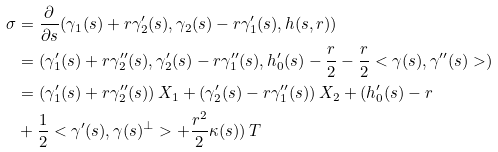Convert formula to latex. <formula><loc_0><loc_0><loc_500><loc_500>\sigma & = \frac { \partial } { \partial s } ( \gamma _ { 1 } ( s ) + r \gamma _ { 2 } ^ { \prime } ( s ) , \gamma _ { 2 } ( s ) - r \gamma _ { 1 } ^ { \prime } ( s ) , h ( s , r ) ) \\ & = ( \gamma _ { 1 } ^ { \prime } ( s ) + r \gamma _ { 2 } ^ { \prime \prime } ( s ) , \gamma _ { 2 } ^ { \prime } ( s ) - r \gamma _ { 1 } ^ { \prime \prime } ( s ) , h _ { 0 } ^ { \prime } ( s ) - \frac { r } { 2 } - \frac { r } { 2 } < \gamma ( s ) , \gamma ^ { \prime \prime } ( s ) > ) \\ & = ( \gamma _ { 1 } ^ { \prime } ( s ) + r \gamma _ { 2 } ^ { \prime \prime } ( s ) ) \, X _ { 1 } + ( \gamma _ { 2 } ^ { \prime } ( s ) - r \gamma _ { 1 } ^ { \prime \prime } ( s ) ) \, X _ { 2 } + ( h _ { 0 } ^ { \prime } ( s ) - r \\ & + \frac { 1 } { 2 } < \gamma ^ { \prime } ( s ) , \gamma ( s ) ^ { \perp } > + \frac { r ^ { 2 } } { 2 } \kappa ( s ) ) \, T</formula> 